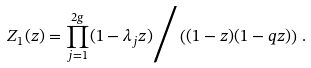<formula> <loc_0><loc_0><loc_500><loc_500>Z _ { 1 } ( z ) = \prod _ { j = 1 } ^ { 2 g } ( 1 - \lambda _ { j } z ) \Big / \left ( ( 1 - z ) ( 1 - q z ) \right ) \, .</formula> 